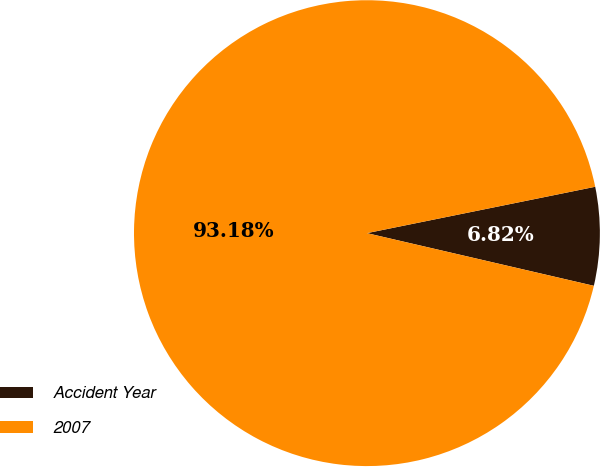Convert chart. <chart><loc_0><loc_0><loc_500><loc_500><pie_chart><fcel>Accident Year<fcel>2007<nl><fcel>6.82%<fcel>93.18%<nl></chart> 